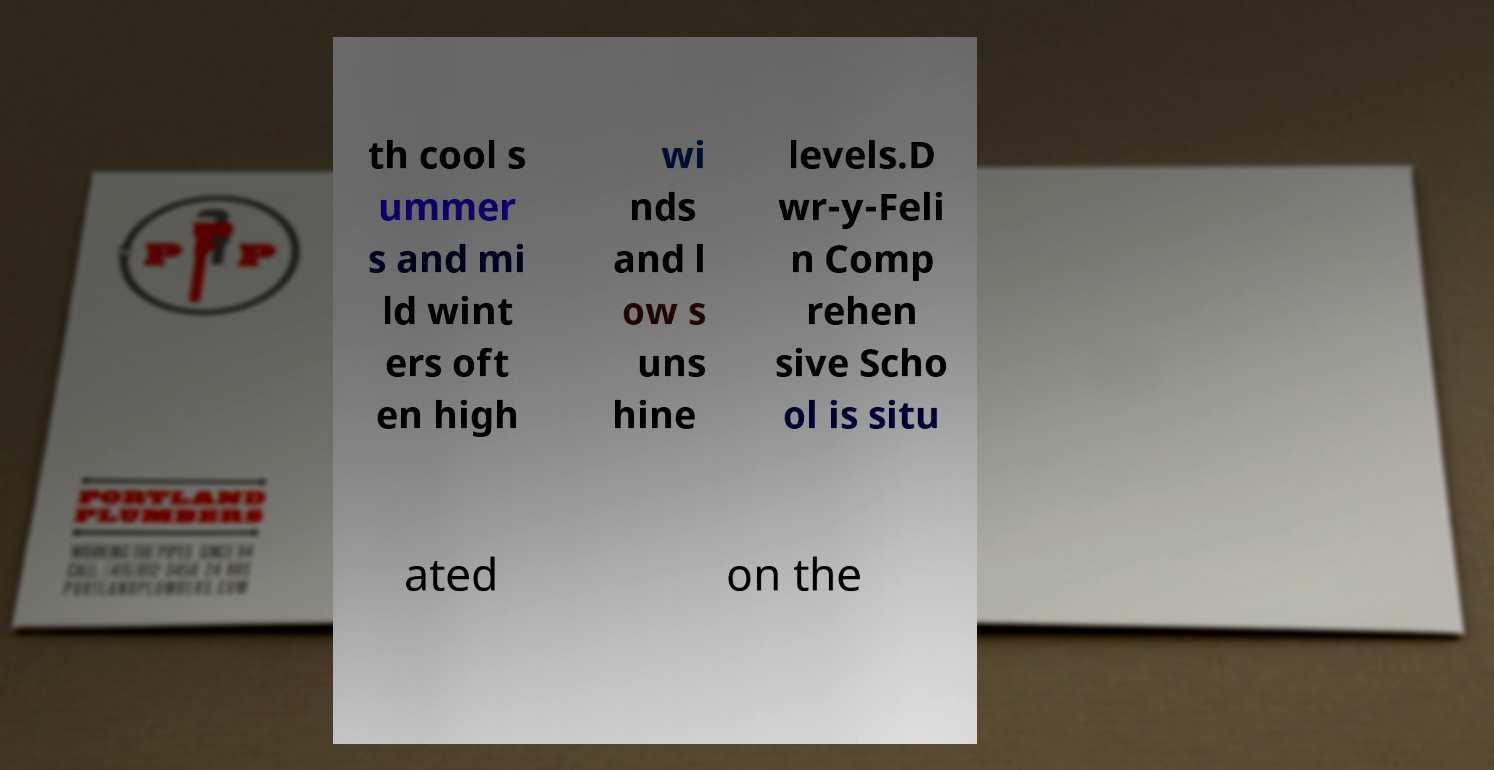Can you accurately transcribe the text from the provided image for me? th cool s ummer s and mi ld wint ers oft en high wi nds and l ow s uns hine levels.D wr-y-Feli n Comp rehen sive Scho ol is situ ated on the 